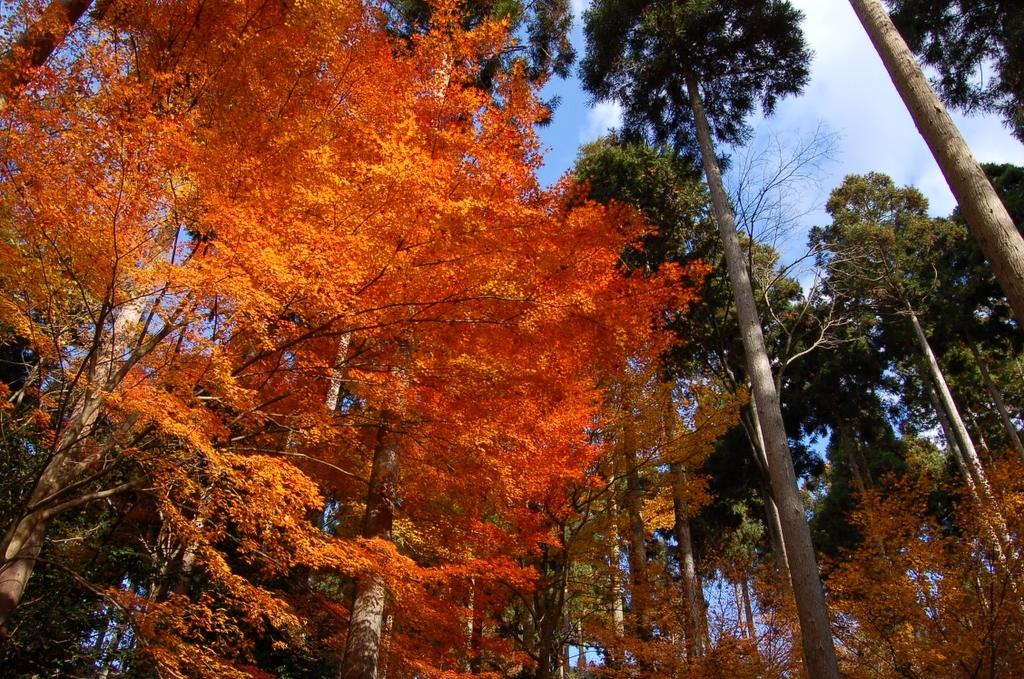What type of vegetation can be seen in the image? There are trees in the image. What is the color and condition of the sky in the image? The sky is blue and cloudy in the image. What type of button can be seen on the canvas in the image? There is no button or canvas present in the image; it only features trees and a blue, cloudy sky. 